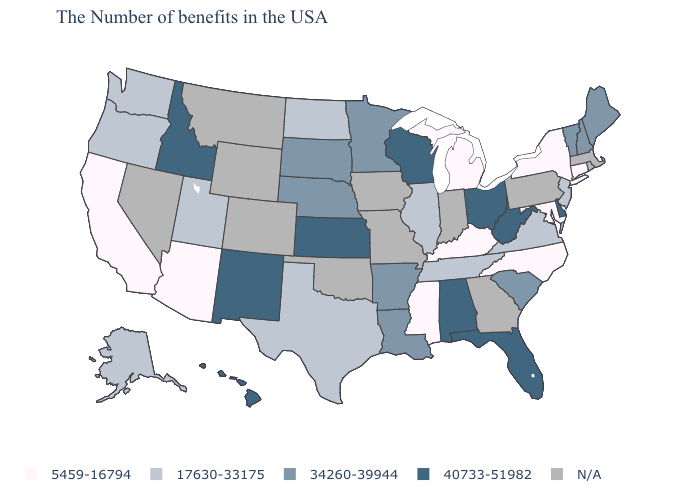Does the map have missing data?
Answer briefly. Yes. Name the states that have a value in the range 5459-16794?
Concise answer only. Connecticut, New York, Maryland, North Carolina, Michigan, Kentucky, Mississippi, Arizona, California. Is the legend a continuous bar?
Give a very brief answer. No. What is the highest value in the USA?
Give a very brief answer. 40733-51982. What is the highest value in the USA?
Answer briefly. 40733-51982. Which states have the lowest value in the South?
Short answer required. Maryland, North Carolina, Kentucky, Mississippi. What is the value of North Dakota?
Write a very short answer. 17630-33175. Which states have the highest value in the USA?
Short answer required. Delaware, West Virginia, Ohio, Florida, Alabama, Wisconsin, Kansas, New Mexico, Idaho, Hawaii. What is the highest value in the South ?
Short answer required. 40733-51982. Does Florida have the lowest value in the USA?
Quick response, please. No. Among the states that border New Jersey , does Delaware have the lowest value?
Keep it brief. No. Which states hav the highest value in the South?
Keep it brief. Delaware, West Virginia, Florida, Alabama. 